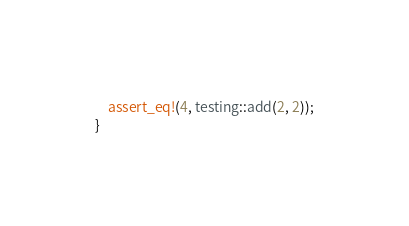<code> <loc_0><loc_0><loc_500><loc_500><_Rust_>    assert_eq!(4, testing::add(2, 2));
}</code> 